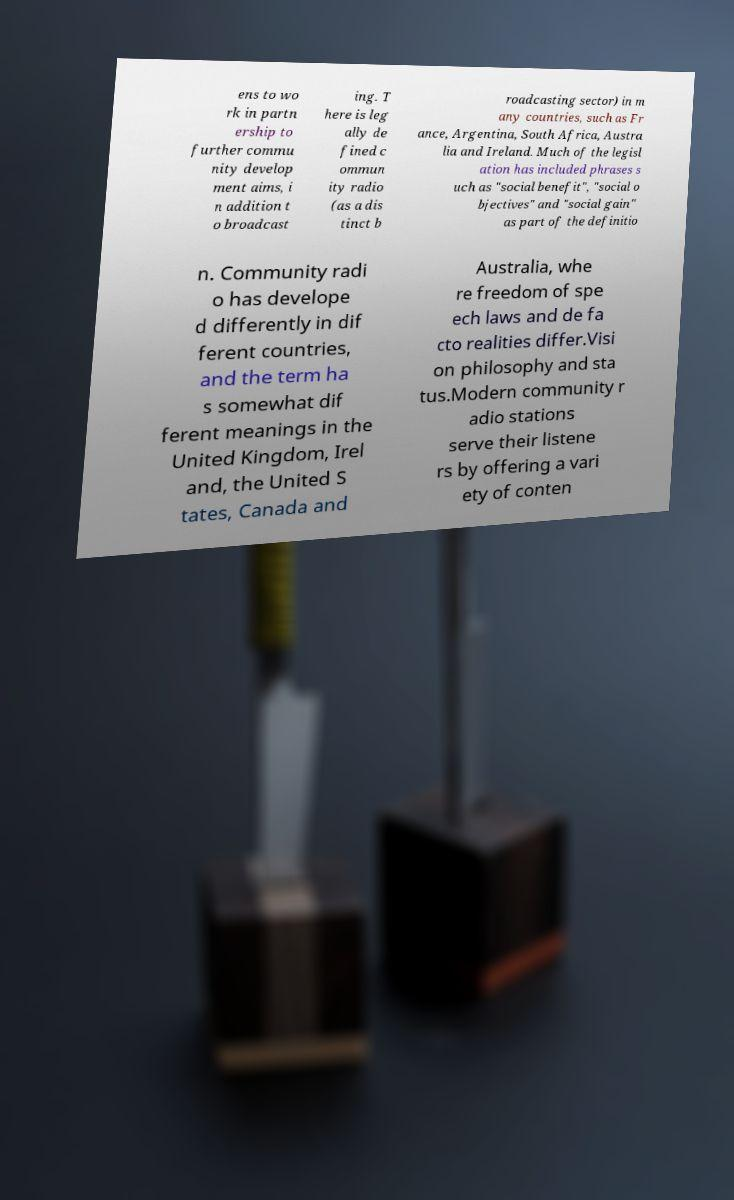There's text embedded in this image that I need extracted. Can you transcribe it verbatim? ens to wo rk in partn ership to further commu nity develop ment aims, i n addition t o broadcast ing. T here is leg ally de fined c ommun ity radio (as a dis tinct b roadcasting sector) in m any countries, such as Fr ance, Argentina, South Africa, Austra lia and Ireland. Much of the legisl ation has included phrases s uch as "social benefit", "social o bjectives" and "social gain" as part of the definitio n. Community radi o has develope d differently in dif ferent countries, and the term ha s somewhat dif ferent meanings in the United Kingdom, Irel and, the United S tates, Canada and Australia, whe re freedom of spe ech laws and de fa cto realities differ.Visi on philosophy and sta tus.Modern community r adio stations serve their listene rs by offering a vari ety of conten 